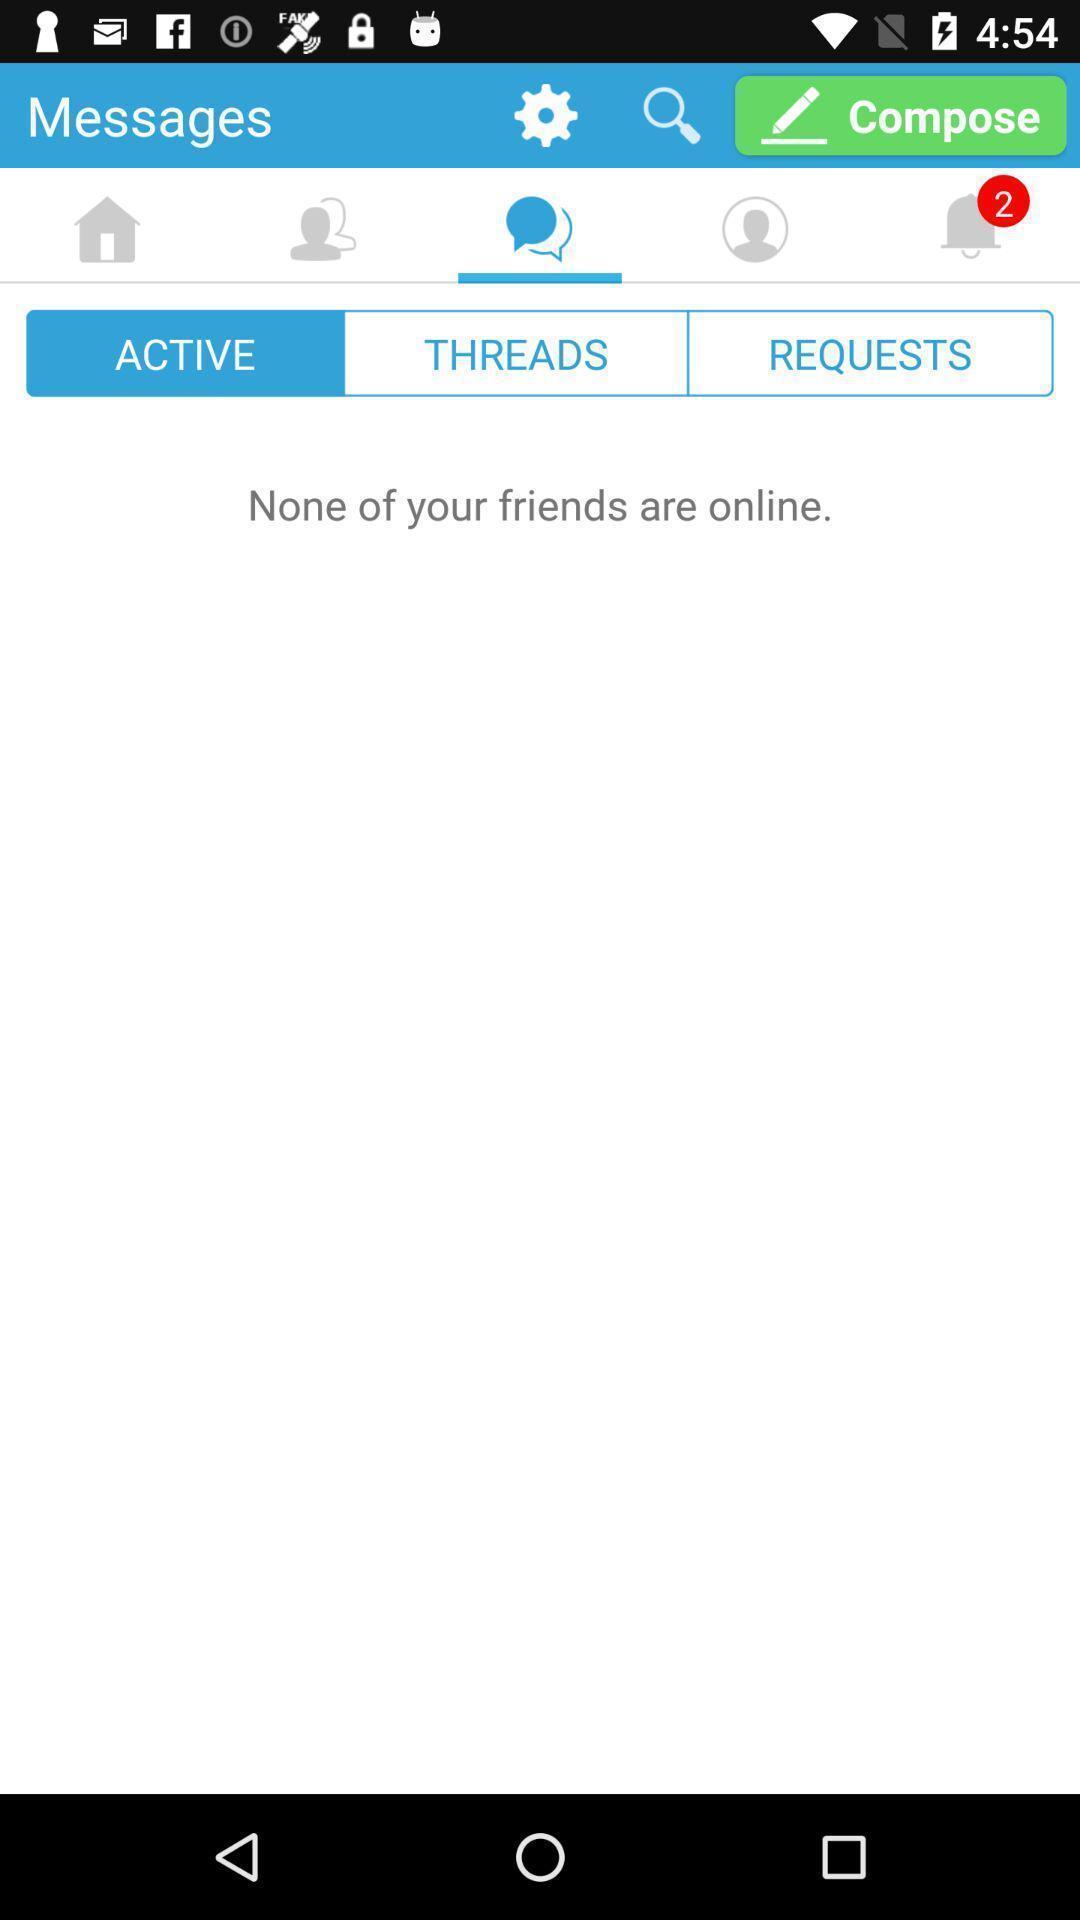Provide a textual representation of this image. Screen shows messages with multiple options. 